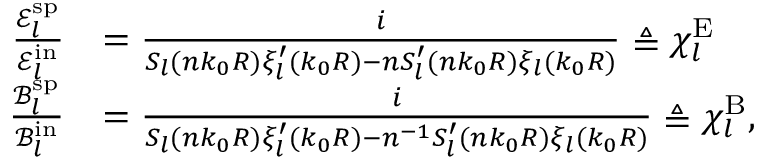Convert formula to latex. <formula><loc_0><loc_0><loc_500><loc_500>\begin{array} { r l } { \frac { \mathcal { E } _ { l } ^ { s p } } { \mathcal { E } _ { l } ^ { i n } } } & { = \frac { i } { S _ { l } ( n k _ { 0 } R ) \xi _ { l } ^ { \prime } ( k _ { 0 } R ) - n S _ { l } ^ { \prime } ( n k _ { 0 } R ) \xi _ { l } ( k _ { 0 } R ) } \triangle q \chi _ { l } ^ { E } } \\ { \frac { \mathcal { B } _ { l } ^ { s p } } { \mathcal { B } _ { l } ^ { i n } } } & { = \frac { i } { S _ { l } ( n k _ { 0 } R ) \xi _ { l } ^ { \prime } ( k _ { 0 } R ) - n ^ { - 1 } S _ { l } ^ { \prime } ( n k _ { 0 } R ) \xi _ { l } ( k _ { 0 } R ) } \triangle q \chi _ { l } ^ { B } , } \end{array}</formula> 